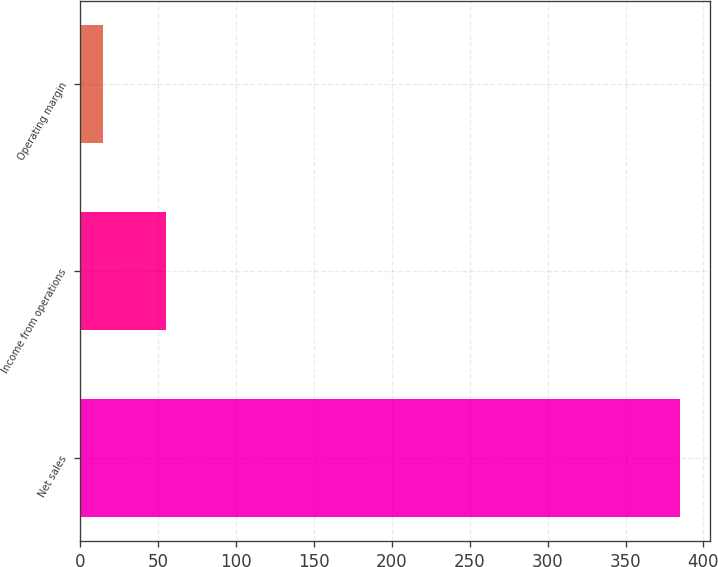Convert chart. <chart><loc_0><loc_0><loc_500><loc_500><bar_chart><fcel>Net sales<fcel>Income from operations<fcel>Operating margin<nl><fcel>385<fcel>55<fcel>14.3<nl></chart> 